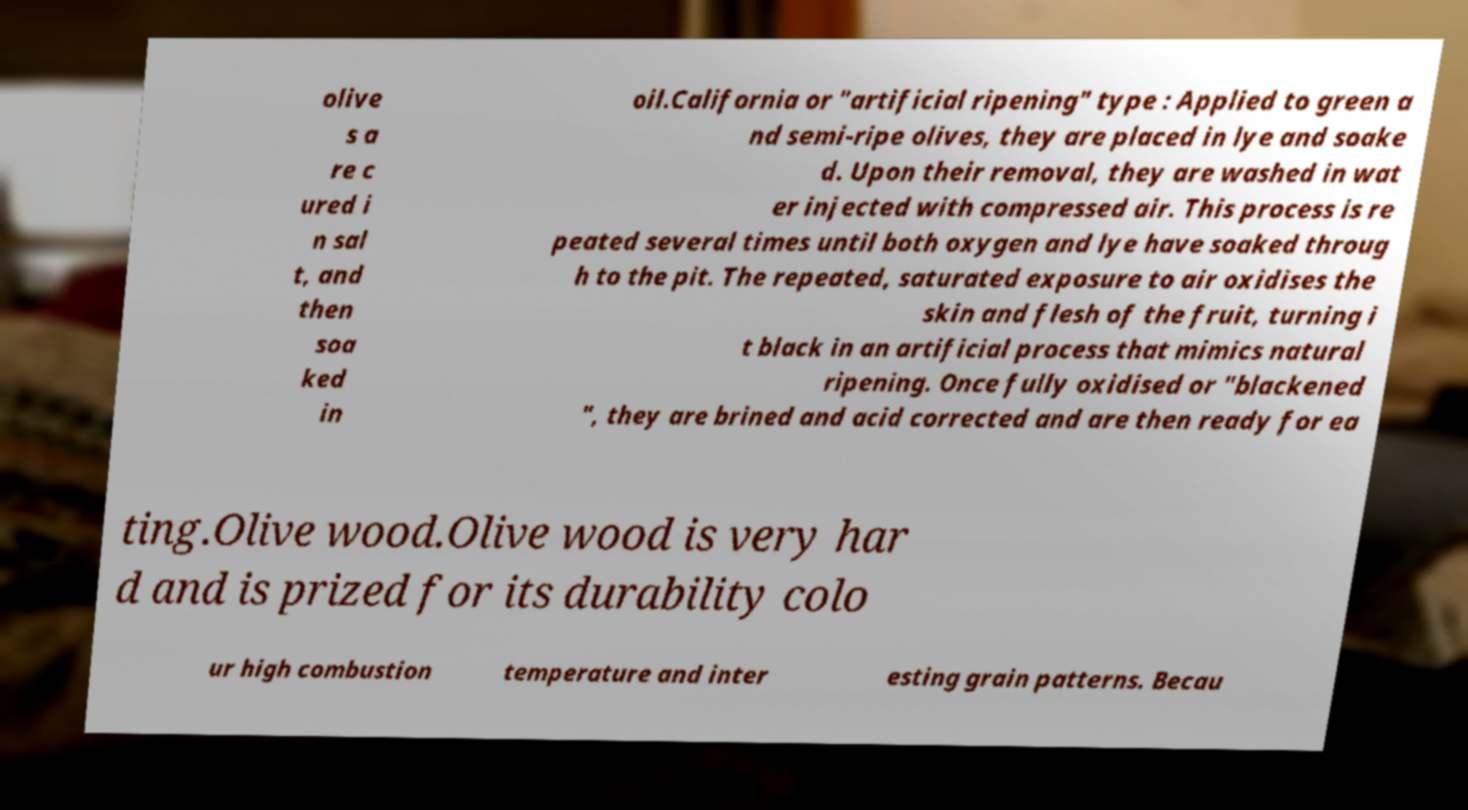There's text embedded in this image that I need extracted. Can you transcribe it verbatim? olive s a re c ured i n sal t, and then soa ked in oil.California or "artificial ripening" type : Applied to green a nd semi-ripe olives, they are placed in lye and soake d. Upon their removal, they are washed in wat er injected with compressed air. This process is re peated several times until both oxygen and lye have soaked throug h to the pit. The repeated, saturated exposure to air oxidises the skin and flesh of the fruit, turning i t black in an artificial process that mimics natural ripening. Once fully oxidised or "blackened ", they are brined and acid corrected and are then ready for ea ting.Olive wood.Olive wood is very har d and is prized for its durability colo ur high combustion temperature and inter esting grain patterns. Becau 